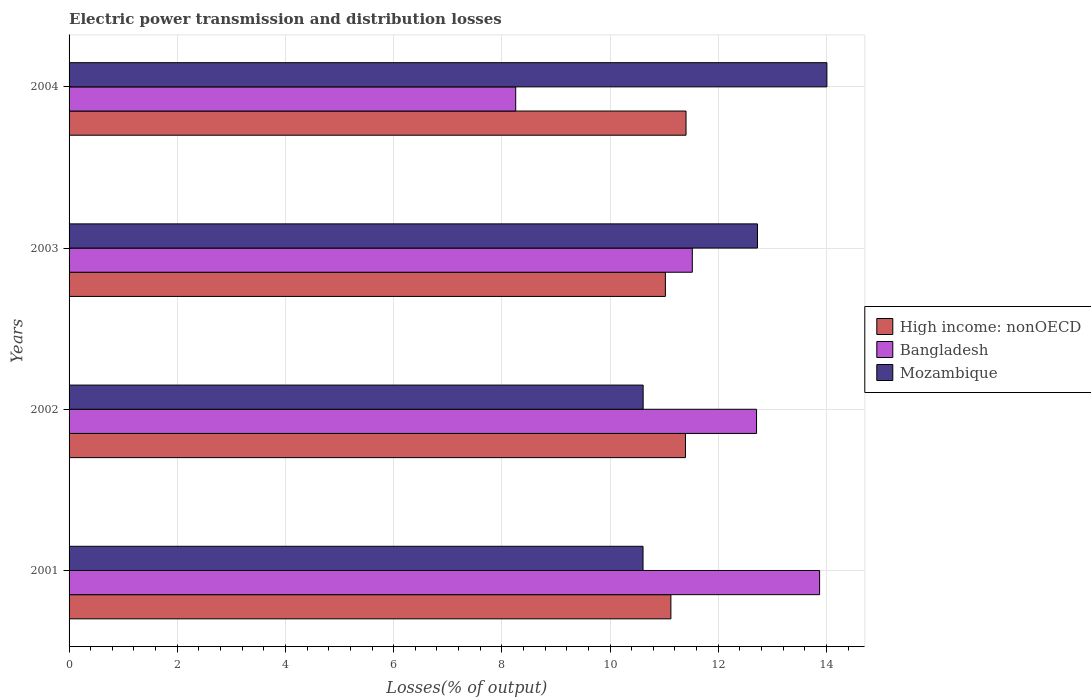How many different coloured bars are there?
Offer a very short reply. 3. How many groups of bars are there?
Your answer should be compact. 4. Are the number of bars per tick equal to the number of legend labels?
Give a very brief answer. Yes. How many bars are there on the 1st tick from the bottom?
Your response must be concise. 3. What is the label of the 1st group of bars from the top?
Ensure brevity in your answer.  2004. What is the electric power transmission and distribution losses in Mozambique in 2002?
Your answer should be very brief. 10.61. Across all years, what is the maximum electric power transmission and distribution losses in Bangladesh?
Your answer should be compact. 13.87. Across all years, what is the minimum electric power transmission and distribution losses in High income: nonOECD?
Keep it short and to the point. 11.02. What is the total electric power transmission and distribution losses in Bangladesh in the graph?
Give a very brief answer. 46.36. What is the difference between the electric power transmission and distribution losses in Bangladesh in 2002 and that in 2004?
Provide a short and direct response. 4.45. What is the difference between the electric power transmission and distribution losses in Mozambique in 2001 and the electric power transmission and distribution losses in Bangladesh in 2003?
Provide a short and direct response. -0.91. What is the average electric power transmission and distribution losses in Bangladesh per year?
Your answer should be very brief. 11.59. In the year 2004, what is the difference between the electric power transmission and distribution losses in Bangladesh and electric power transmission and distribution losses in Mozambique?
Your answer should be compact. -5.75. What is the ratio of the electric power transmission and distribution losses in Mozambique in 2001 to that in 2004?
Make the answer very short. 0.76. Is the difference between the electric power transmission and distribution losses in Bangladesh in 2003 and 2004 greater than the difference between the electric power transmission and distribution losses in Mozambique in 2003 and 2004?
Give a very brief answer. Yes. What is the difference between the highest and the second highest electric power transmission and distribution losses in Mozambique?
Keep it short and to the point. 1.28. What is the difference between the highest and the lowest electric power transmission and distribution losses in High income: nonOECD?
Ensure brevity in your answer.  0.38. In how many years, is the electric power transmission and distribution losses in Mozambique greater than the average electric power transmission and distribution losses in Mozambique taken over all years?
Give a very brief answer. 2. Is the sum of the electric power transmission and distribution losses in High income: nonOECD in 2001 and 2003 greater than the maximum electric power transmission and distribution losses in Bangladesh across all years?
Your response must be concise. Yes. What does the 1st bar from the top in 2003 represents?
Your answer should be compact. Mozambique. Is it the case that in every year, the sum of the electric power transmission and distribution losses in Bangladesh and electric power transmission and distribution losses in High income: nonOECD is greater than the electric power transmission and distribution losses in Mozambique?
Your response must be concise. Yes. Are all the bars in the graph horizontal?
Your answer should be compact. Yes. How many years are there in the graph?
Give a very brief answer. 4. What is the difference between two consecutive major ticks on the X-axis?
Your response must be concise. 2. How are the legend labels stacked?
Offer a terse response. Vertical. What is the title of the graph?
Keep it short and to the point. Electric power transmission and distribution losses. What is the label or title of the X-axis?
Give a very brief answer. Losses(% of output). What is the label or title of the Y-axis?
Your answer should be very brief. Years. What is the Losses(% of output) of High income: nonOECD in 2001?
Your answer should be very brief. 11.13. What is the Losses(% of output) in Bangladesh in 2001?
Offer a very short reply. 13.87. What is the Losses(% of output) in Mozambique in 2001?
Offer a terse response. 10.61. What is the Losses(% of output) in High income: nonOECD in 2002?
Offer a terse response. 11.39. What is the Losses(% of output) in Bangladesh in 2002?
Provide a succinct answer. 12.71. What is the Losses(% of output) of Mozambique in 2002?
Make the answer very short. 10.61. What is the Losses(% of output) of High income: nonOECD in 2003?
Your response must be concise. 11.02. What is the Losses(% of output) of Bangladesh in 2003?
Provide a short and direct response. 11.52. What is the Losses(% of output) in Mozambique in 2003?
Ensure brevity in your answer.  12.73. What is the Losses(% of output) in High income: nonOECD in 2004?
Your answer should be very brief. 11.4. What is the Losses(% of output) in Bangladesh in 2004?
Ensure brevity in your answer.  8.26. What is the Losses(% of output) in Mozambique in 2004?
Your response must be concise. 14.01. Across all years, what is the maximum Losses(% of output) of High income: nonOECD?
Make the answer very short. 11.4. Across all years, what is the maximum Losses(% of output) of Bangladesh?
Provide a succinct answer. 13.87. Across all years, what is the maximum Losses(% of output) of Mozambique?
Make the answer very short. 14.01. Across all years, what is the minimum Losses(% of output) of High income: nonOECD?
Your answer should be compact. 11.02. Across all years, what is the minimum Losses(% of output) of Bangladesh?
Keep it short and to the point. 8.26. Across all years, what is the minimum Losses(% of output) in Mozambique?
Make the answer very short. 10.61. What is the total Losses(% of output) of High income: nonOECD in the graph?
Your answer should be compact. 44.95. What is the total Losses(% of output) of Bangladesh in the graph?
Offer a terse response. 46.36. What is the total Losses(% of output) in Mozambique in the graph?
Make the answer very short. 47.96. What is the difference between the Losses(% of output) of High income: nonOECD in 2001 and that in 2002?
Your response must be concise. -0.27. What is the difference between the Losses(% of output) in Bangladesh in 2001 and that in 2002?
Offer a very short reply. 1.17. What is the difference between the Losses(% of output) of Mozambique in 2001 and that in 2002?
Offer a terse response. -0. What is the difference between the Losses(% of output) in High income: nonOECD in 2001 and that in 2003?
Make the answer very short. 0.1. What is the difference between the Losses(% of output) of Bangladesh in 2001 and that in 2003?
Make the answer very short. 2.35. What is the difference between the Losses(% of output) of Mozambique in 2001 and that in 2003?
Offer a terse response. -2.12. What is the difference between the Losses(% of output) in High income: nonOECD in 2001 and that in 2004?
Provide a succinct answer. -0.28. What is the difference between the Losses(% of output) of Bangladesh in 2001 and that in 2004?
Offer a very short reply. 5.62. What is the difference between the Losses(% of output) of Mozambique in 2001 and that in 2004?
Give a very brief answer. -3.4. What is the difference between the Losses(% of output) of High income: nonOECD in 2002 and that in 2003?
Offer a very short reply. 0.37. What is the difference between the Losses(% of output) in Bangladesh in 2002 and that in 2003?
Provide a short and direct response. 1.19. What is the difference between the Losses(% of output) in Mozambique in 2002 and that in 2003?
Provide a succinct answer. -2.11. What is the difference between the Losses(% of output) of High income: nonOECD in 2002 and that in 2004?
Provide a short and direct response. -0.01. What is the difference between the Losses(% of output) in Bangladesh in 2002 and that in 2004?
Make the answer very short. 4.45. What is the difference between the Losses(% of output) of Mozambique in 2002 and that in 2004?
Offer a very short reply. -3.4. What is the difference between the Losses(% of output) in High income: nonOECD in 2003 and that in 2004?
Offer a terse response. -0.38. What is the difference between the Losses(% of output) in Bangladesh in 2003 and that in 2004?
Your answer should be compact. 3.26. What is the difference between the Losses(% of output) in Mozambique in 2003 and that in 2004?
Offer a very short reply. -1.28. What is the difference between the Losses(% of output) in High income: nonOECD in 2001 and the Losses(% of output) in Bangladesh in 2002?
Your answer should be very brief. -1.58. What is the difference between the Losses(% of output) in High income: nonOECD in 2001 and the Losses(% of output) in Mozambique in 2002?
Keep it short and to the point. 0.51. What is the difference between the Losses(% of output) of Bangladesh in 2001 and the Losses(% of output) of Mozambique in 2002?
Your response must be concise. 3.26. What is the difference between the Losses(% of output) of High income: nonOECD in 2001 and the Losses(% of output) of Bangladesh in 2003?
Your answer should be compact. -0.4. What is the difference between the Losses(% of output) in High income: nonOECD in 2001 and the Losses(% of output) in Mozambique in 2003?
Offer a terse response. -1.6. What is the difference between the Losses(% of output) of Bangladesh in 2001 and the Losses(% of output) of Mozambique in 2003?
Offer a terse response. 1.15. What is the difference between the Losses(% of output) in High income: nonOECD in 2001 and the Losses(% of output) in Bangladesh in 2004?
Your answer should be compact. 2.87. What is the difference between the Losses(% of output) of High income: nonOECD in 2001 and the Losses(% of output) of Mozambique in 2004?
Offer a terse response. -2.88. What is the difference between the Losses(% of output) in Bangladesh in 2001 and the Losses(% of output) in Mozambique in 2004?
Keep it short and to the point. -0.13. What is the difference between the Losses(% of output) of High income: nonOECD in 2002 and the Losses(% of output) of Bangladesh in 2003?
Your response must be concise. -0.13. What is the difference between the Losses(% of output) of High income: nonOECD in 2002 and the Losses(% of output) of Mozambique in 2003?
Offer a terse response. -1.33. What is the difference between the Losses(% of output) of Bangladesh in 2002 and the Losses(% of output) of Mozambique in 2003?
Provide a succinct answer. -0.02. What is the difference between the Losses(% of output) of High income: nonOECD in 2002 and the Losses(% of output) of Bangladesh in 2004?
Keep it short and to the point. 3.14. What is the difference between the Losses(% of output) of High income: nonOECD in 2002 and the Losses(% of output) of Mozambique in 2004?
Offer a terse response. -2.61. What is the difference between the Losses(% of output) in Bangladesh in 2002 and the Losses(% of output) in Mozambique in 2004?
Provide a succinct answer. -1.3. What is the difference between the Losses(% of output) in High income: nonOECD in 2003 and the Losses(% of output) in Bangladesh in 2004?
Give a very brief answer. 2.77. What is the difference between the Losses(% of output) in High income: nonOECD in 2003 and the Losses(% of output) in Mozambique in 2004?
Make the answer very short. -2.99. What is the difference between the Losses(% of output) of Bangladesh in 2003 and the Losses(% of output) of Mozambique in 2004?
Provide a succinct answer. -2.49. What is the average Losses(% of output) in High income: nonOECD per year?
Offer a terse response. 11.24. What is the average Losses(% of output) of Bangladesh per year?
Your answer should be compact. 11.59. What is the average Losses(% of output) of Mozambique per year?
Ensure brevity in your answer.  11.99. In the year 2001, what is the difference between the Losses(% of output) of High income: nonOECD and Losses(% of output) of Bangladesh?
Offer a very short reply. -2.75. In the year 2001, what is the difference between the Losses(% of output) of High income: nonOECD and Losses(% of output) of Mozambique?
Your answer should be very brief. 0.52. In the year 2001, what is the difference between the Losses(% of output) in Bangladesh and Losses(% of output) in Mozambique?
Your answer should be very brief. 3.26. In the year 2002, what is the difference between the Losses(% of output) in High income: nonOECD and Losses(% of output) in Bangladesh?
Your answer should be compact. -1.31. In the year 2002, what is the difference between the Losses(% of output) of High income: nonOECD and Losses(% of output) of Mozambique?
Keep it short and to the point. 0.78. In the year 2002, what is the difference between the Losses(% of output) of Bangladesh and Losses(% of output) of Mozambique?
Give a very brief answer. 2.1. In the year 2003, what is the difference between the Losses(% of output) of High income: nonOECD and Losses(% of output) of Bangladesh?
Your response must be concise. -0.5. In the year 2003, what is the difference between the Losses(% of output) of High income: nonOECD and Losses(% of output) of Mozambique?
Ensure brevity in your answer.  -1.7. In the year 2003, what is the difference between the Losses(% of output) of Bangladesh and Losses(% of output) of Mozambique?
Ensure brevity in your answer.  -1.2. In the year 2004, what is the difference between the Losses(% of output) in High income: nonOECD and Losses(% of output) in Bangladesh?
Keep it short and to the point. 3.15. In the year 2004, what is the difference between the Losses(% of output) of High income: nonOECD and Losses(% of output) of Mozambique?
Provide a short and direct response. -2.6. In the year 2004, what is the difference between the Losses(% of output) in Bangladesh and Losses(% of output) in Mozambique?
Provide a short and direct response. -5.75. What is the ratio of the Losses(% of output) of High income: nonOECD in 2001 to that in 2002?
Give a very brief answer. 0.98. What is the ratio of the Losses(% of output) of Bangladesh in 2001 to that in 2002?
Give a very brief answer. 1.09. What is the ratio of the Losses(% of output) of Mozambique in 2001 to that in 2002?
Your answer should be very brief. 1. What is the ratio of the Losses(% of output) of High income: nonOECD in 2001 to that in 2003?
Give a very brief answer. 1.01. What is the ratio of the Losses(% of output) of Bangladesh in 2001 to that in 2003?
Make the answer very short. 1.2. What is the ratio of the Losses(% of output) in Mozambique in 2001 to that in 2003?
Your answer should be compact. 0.83. What is the ratio of the Losses(% of output) of High income: nonOECD in 2001 to that in 2004?
Offer a terse response. 0.98. What is the ratio of the Losses(% of output) of Bangladesh in 2001 to that in 2004?
Ensure brevity in your answer.  1.68. What is the ratio of the Losses(% of output) in Mozambique in 2001 to that in 2004?
Offer a very short reply. 0.76. What is the ratio of the Losses(% of output) in High income: nonOECD in 2002 to that in 2003?
Provide a short and direct response. 1.03. What is the ratio of the Losses(% of output) of Bangladesh in 2002 to that in 2003?
Give a very brief answer. 1.1. What is the ratio of the Losses(% of output) of Mozambique in 2002 to that in 2003?
Make the answer very short. 0.83. What is the ratio of the Losses(% of output) in Bangladesh in 2002 to that in 2004?
Provide a short and direct response. 1.54. What is the ratio of the Losses(% of output) in Mozambique in 2002 to that in 2004?
Your answer should be compact. 0.76. What is the ratio of the Losses(% of output) of High income: nonOECD in 2003 to that in 2004?
Keep it short and to the point. 0.97. What is the ratio of the Losses(% of output) of Bangladesh in 2003 to that in 2004?
Your response must be concise. 1.4. What is the ratio of the Losses(% of output) in Mozambique in 2003 to that in 2004?
Your answer should be compact. 0.91. What is the difference between the highest and the second highest Losses(% of output) in High income: nonOECD?
Give a very brief answer. 0.01. What is the difference between the highest and the second highest Losses(% of output) of Bangladesh?
Provide a short and direct response. 1.17. What is the difference between the highest and the second highest Losses(% of output) in Mozambique?
Give a very brief answer. 1.28. What is the difference between the highest and the lowest Losses(% of output) in High income: nonOECD?
Provide a succinct answer. 0.38. What is the difference between the highest and the lowest Losses(% of output) in Bangladesh?
Your answer should be compact. 5.62. What is the difference between the highest and the lowest Losses(% of output) in Mozambique?
Your response must be concise. 3.4. 